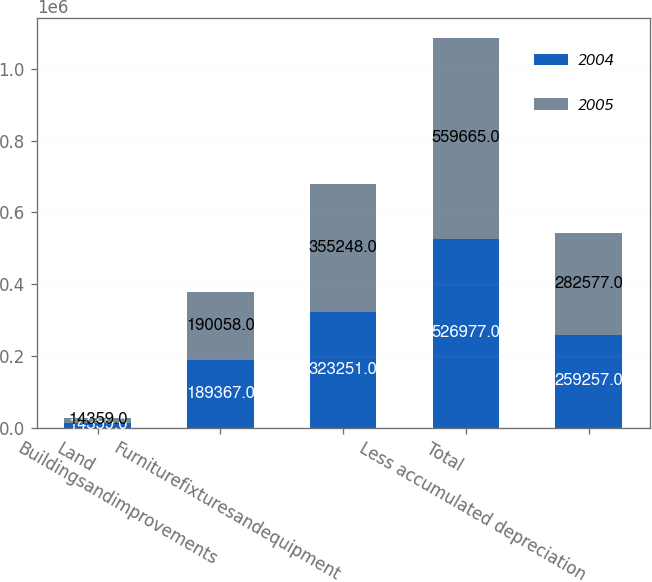Convert chart to OTSL. <chart><loc_0><loc_0><loc_500><loc_500><stacked_bar_chart><ecel><fcel>Land<fcel>Buildingsandimprovements<fcel>Furniturefixturesandequipment<fcel>Total<fcel>Less accumulated depreciation<nl><fcel>2004<fcel>14359<fcel>189367<fcel>323251<fcel>526977<fcel>259257<nl><fcel>2005<fcel>14359<fcel>190058<fcel>355248<fcel>559665<fcel>282577<nl></chart> 